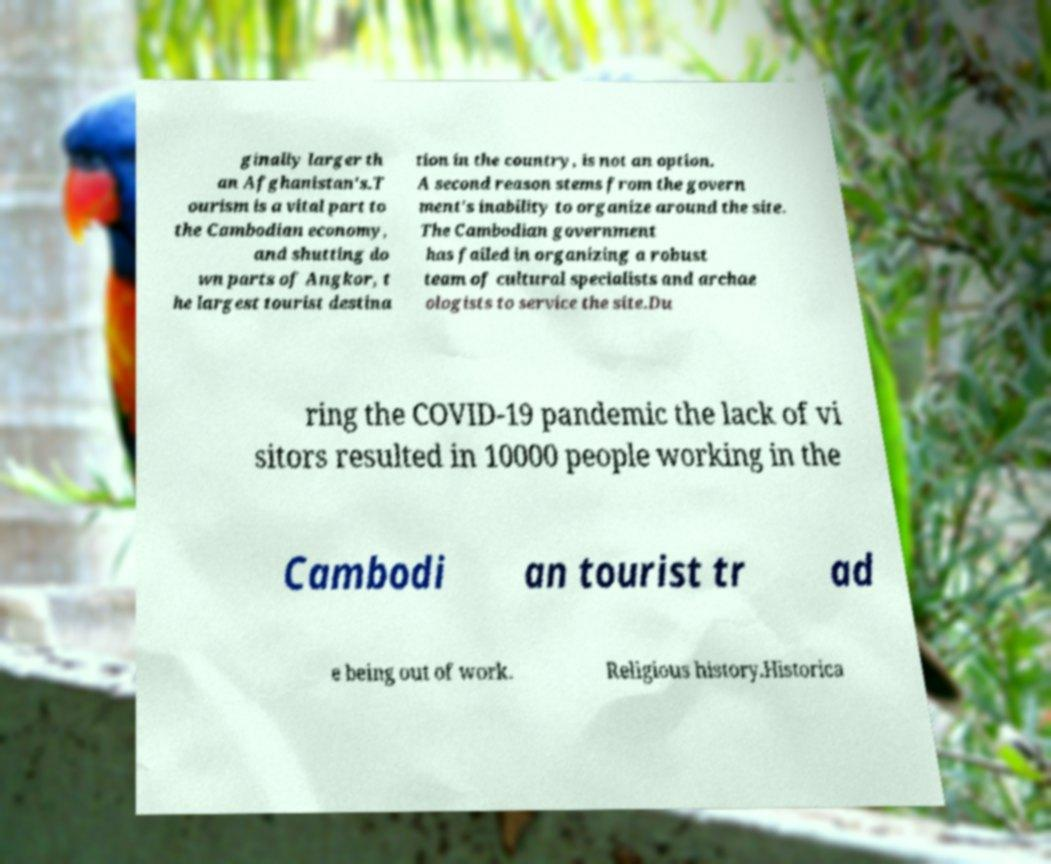There's text embedded in this image that I need extracted. Can you transcribe it verbatim? ginally larger th an Afghanistan's.T ourism is a vital part to the Cambodian economy, and shutting do wn parts of Angkor, t he largest tourist destina tion in the country, is not an option. A second reason stems from the govern ment's inability to organize around the site. The Cambodian government has failed in organizing a robust team of cultural specialists and archae ologists to service the site.Du ring the COVID-19 pandemic the lack of vi sitors resulted in 10000 people working in the Cambodi an tourist tr ad e being out of work. Religious history.Historica 